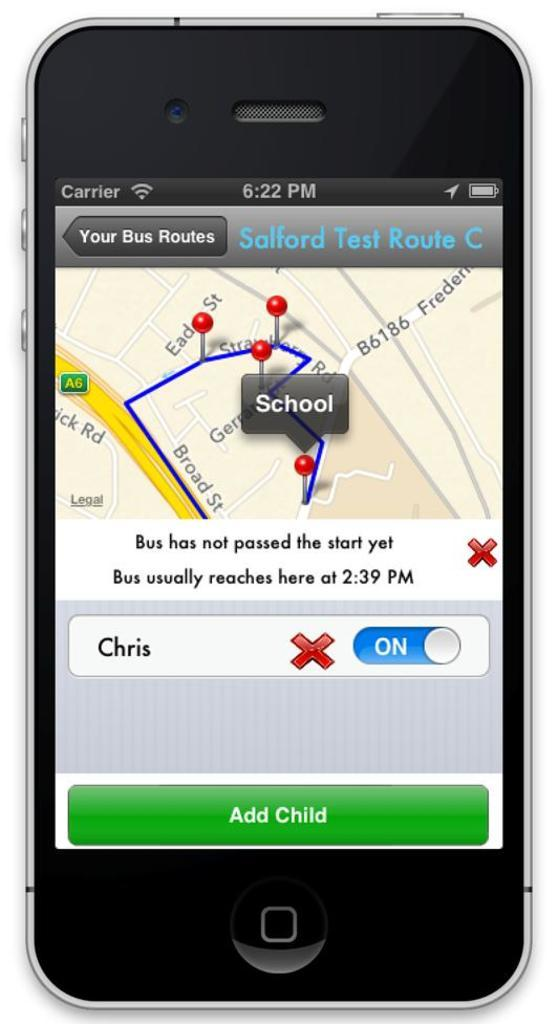<image>
Describe the image concisely. A black smartphone is tracking a child named Chris's school bus. 